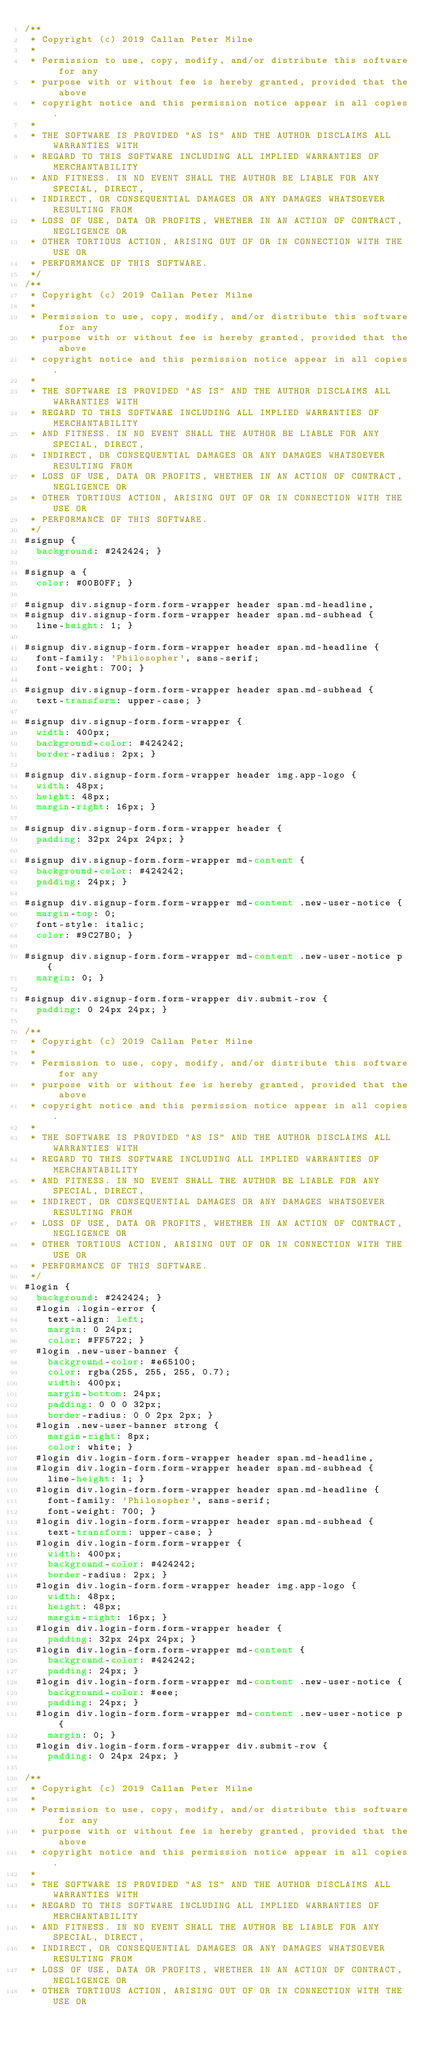<code> <loc_0><loc_0><loc_500><loc_500><_CSS_>/**
 * Copyright (c) 2019 Callan Peter Milne
 *
 * Permission to use, copy, modify, and/or distribute this software for any
 * purpose with or without fee is hereby granted, provided that the above
 * copyright notice and this permission notice appear in all copies.
 *
 * THE SOFTWARE IS PROVIDED "AS IS" AND THE AUTHOR DISCLAIMS ALL WARRANTIES WITH
 * REGARD TO THIS SOFTWARE INCLUDING ALL IMPLIED WARRANTIES OF MERCHANTABILITY
 * AND FITNESS. IN NO EVENT SHALL THE AUTHOR BE LIABLE FOR ANY SPECIAL, DIRECT,
 * INDIRECT, OR CONSEQUENTIAL DAMAGES OR ANY DAMAGES WHATSOEVER RESULTING FROM
 * LOSS OF USE, DATA OR PROFITS, WHETHER IN AN ACTION OF CONTRACT, NEGLIGENCE OR
 * OTHER TORTIOUS ACTION, ARISING OUT OF OR IN CONNECTION WITH THE USE OR
 * PERFORMANCE OF THIS SOFTWARE.
 */
/**
 * Copyright (c) 2019 Callan Peter Milne
 *
 * Permission to use, copy, modify, and/or distribute this software for any
 * purpose with or without fee is hereby granted, provided that the above
 * copyright notice and this permission notice appear in all copies.
 *
 * THE SOFTWARE IS PROVIDED "AS IS" AND THE AUTHOR DISCLAIMS ALL WARRANTIES WITH
 * REGARD TO THIS SOFTWARE INCLUDING ALL IMPLIED WARRANTIES OF MERCHANTABILITY
 * AND FITNESS. IN NO EVENT SHALL THE AUTHOR BE LIABLE FOR ANY SPECIAL, DIRECT,
 * INDIRECT, OR CONSEQUENTIAL DAMAGES OR ANY DAMAGES WHATSOEVER RESULTING FROM
 * LOSS OF USE, DATA OR PROFITS, WHETHER IN AN ACTION OF CONTRACT, NEGLIGENCE OR
 * OTHER TORTIOUS ACTION, ARISING OUT OF OR IN CONNECTION WITH THE USE OR
 * PERFORMANCE OF THIS SOFTWARE.
 */
#signup {
  background: #242424; }

#signup a {
  color: #00B0FF; }

#signup div.signup-form.form-wrapper header span.md-headline,
#signup div.signup-form.form-wrapper header span.md-subhead {
  line-height: 1; }

#signup div.signup-form.form-wrapper header span.md-headline {
  font-family: 'Philosopher', sans-serif;
  font-weight: 700; }

#signup div.signup-form.form-wrapper header span.md-subhead {
  text-transform: upper-case; }

#signup div.signup-form.form-wrapper {
  width: 400px;
  background-color: #424242;
  border-radius: 2px; }

#signup div.signup-form.form-wrapper header img.app-logo {
  width: 48px;
  height: 48px;
  margin-right: 16px; }

#signup div.signup-form.form-wrapper header {
  padding: 32px 24px 24px; }

#signup div.signup-form.form-wrapper md-content {
  background-color: #424242;
  padding: 24px; }

#signup div.signup-form.form-wrapper md-content .new-user-notice {
  margin-top: 0;
  font-style: italic;
  color: #9C27B0; }

#signup div.signup-form.form-wrapper md-content .new-user-notice p {
  margin: 0; }

#signup div.signup-form.form-wrapper div.submit-row {
  padding: 0 24px 24px; }

/**
 * Copyright (c) 2019 Callan Peter Milne
 *
 * Permission to use, copy, modify, and/or distribute this software for any
 * purpose with or without fee is hereby granted, provided that the above
 * copyright notice and this permission notice appear in all copies.
 *
 * THE SOFTWARE IS PROVIDED "AS IS" AND THE AUTHOR DISCLAIMS ALL WARRANTIES WITH
 * REGARD TO THIS SOFTWARE INCLUDING ALL IMPLIED WARRANTIES OF MERCHANTABILITY
 * AND FITNESS. IN NO EVENT SHALL THE AUTHOR BE LIABLE FOR ANY SPECIAL, DIRECT,
 * INDIRECT, OR CONSEQUENTIAL DAMAGES OR ANY DAMAGES WHATSOEVER RESULTING FROM
 * LOSS OF USE, DATA OR PROFITS, WHETHER IN AN ACTION OF CONTRACT, NEGLIGENCE OR
 * OTHER TORTIOUS ACTION, ARISING OUT OF OR IN CONNECTION WITH THE USE OR
 * PERFORMANCE OF THIS SOFTWARE.
 */
#login {
  background: #242424; }
  #login .login-error {
    text-align: left;
    margin: 0 24px;
    color: #FF5722; }
  #login .new-user-banner {
    background-color: #e65100;
    color: rgba(255, 255, 255, 0.7);
    width: 400px;
    margin-bottom: 24px;
    padding: 0 0 0 32px;
    border-radius: 0 0 2px 2px; }
  #login .new-user-banner strong {
    margin-right: 8px;
    color: white; }
  #login div.login-form.form-wrapper header span.md-headline,
  #login div.login-form.form-wrapper header span.md-subhead {
    line-height: 1; }
  #login div.login-form.form-wrapper header span.md-headline {
    font-family: 'Philosopher', sans-serif;
    font-weight: 700; }
  #login div.login-form.form-wrapper header span.md-subhead {
    text-transform: upper-case; }
  #login div.login-form.form-wrapper {
    width: 400px;
    background-color: #424242;
    border-radius: 2px; }
  #login div.login-form.form-wrapper header img.app-logo {
    width: 48px;
    height: 48px;
    margin-right: 16px; }
  #login div.login-form.form-wrapper header {
    padding: 32px 24px 24px; }
  #login div.login-form.form-wrapper md-content {
    background-color: #424242;
    padding: 24px; }
  #login div.login-form.form-wrapper md-content .new-user-notice {
    background-color: #eee;
    padding: 24px; }
  #login div.login-form.form-wrapper md-content .new-user-notice p {
    margin: 0; }
  #login div.login-form.form-wrapper div.submit-row {
    padding: 0 24px 24px; }

/**
 * Copyright (c) 2019 Callan Peter Milne
 *
 * Permission to use, copy, modify, and/or distribute this software for any
 * purpose with or without fee is hereby granted, provided that the above
 * copyright notice and this permission notice appear in all copies.
 *
 * THE SOFTWARE IS PROVIDED "AS IS" AND THE AUTHOR DISCLAIMS ALL WARRANTIES WITH
 * REGARD TO THIS SOFTWARE INCLUDING ALL IMPLIED WARRANTIES OF MERCHANTABILITY
 * AND FITNESS. IN NO EVENT SHALL THE AUTHOR BE LIABLE FOR ANY SPECIAL, DIRECT,
 * INDIRECT, OR CONSEQUENTIAL DAMAGES OR ANY DAMAGES WHATSOEVER RESULTING FROM
 * LOSS OF USE, DATA OR PROFITS, WHETHER IN AN ACTION OF CONTRACT, NEGLIGENCE OR
 * OTHER TORTIOUS ACTION, ARISING OUT OF OR IN CONNECTION WITH THE USE OR</code> 